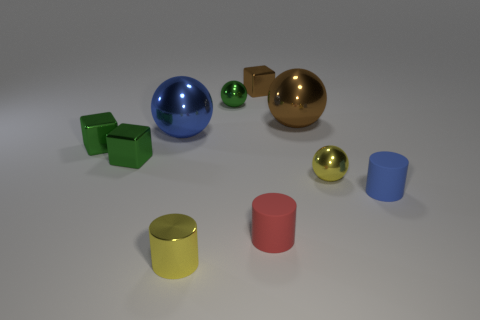What number of small green shiny cubes are to the right of the yellow metal object left of the yellow shiny ball?
Your response must be concise. 0. Are there more metal cylinders than cyan cubes?
Your response must be concise. Yes. Does the big blue sphere have the same material as the brown sphere?
Keep it short and to the point. Yes. Are there the same number of big brown spheres that are behind the metallic cylinder and tiny red things?
Provide a succinct answer. Yes. What number of blue cylinders have the same material as the tiny red thing?
Ensure brevity in your answer.  1. Are there fewer small green shiny things than cyan shiny cylinders?
Give a very brief answer. No. There is a big ball that is to the left of the red cylinder; is it the same color as the metal cylinder?
Your answer should be compact. No. There is a tiny ball that is left of the small ball that is in front of the big blue shiny ball; what number of tiny yellow shiny cylinders are right of it?
Give a very brief answer. 0. There is a small yellow cylinder; what number of green metallic spheres are to the left of it?
Your answer should be very brief. 0. What color is the shiny thing that is the same shape as the small red rubber object?
Offer a terse response. Yellow. 